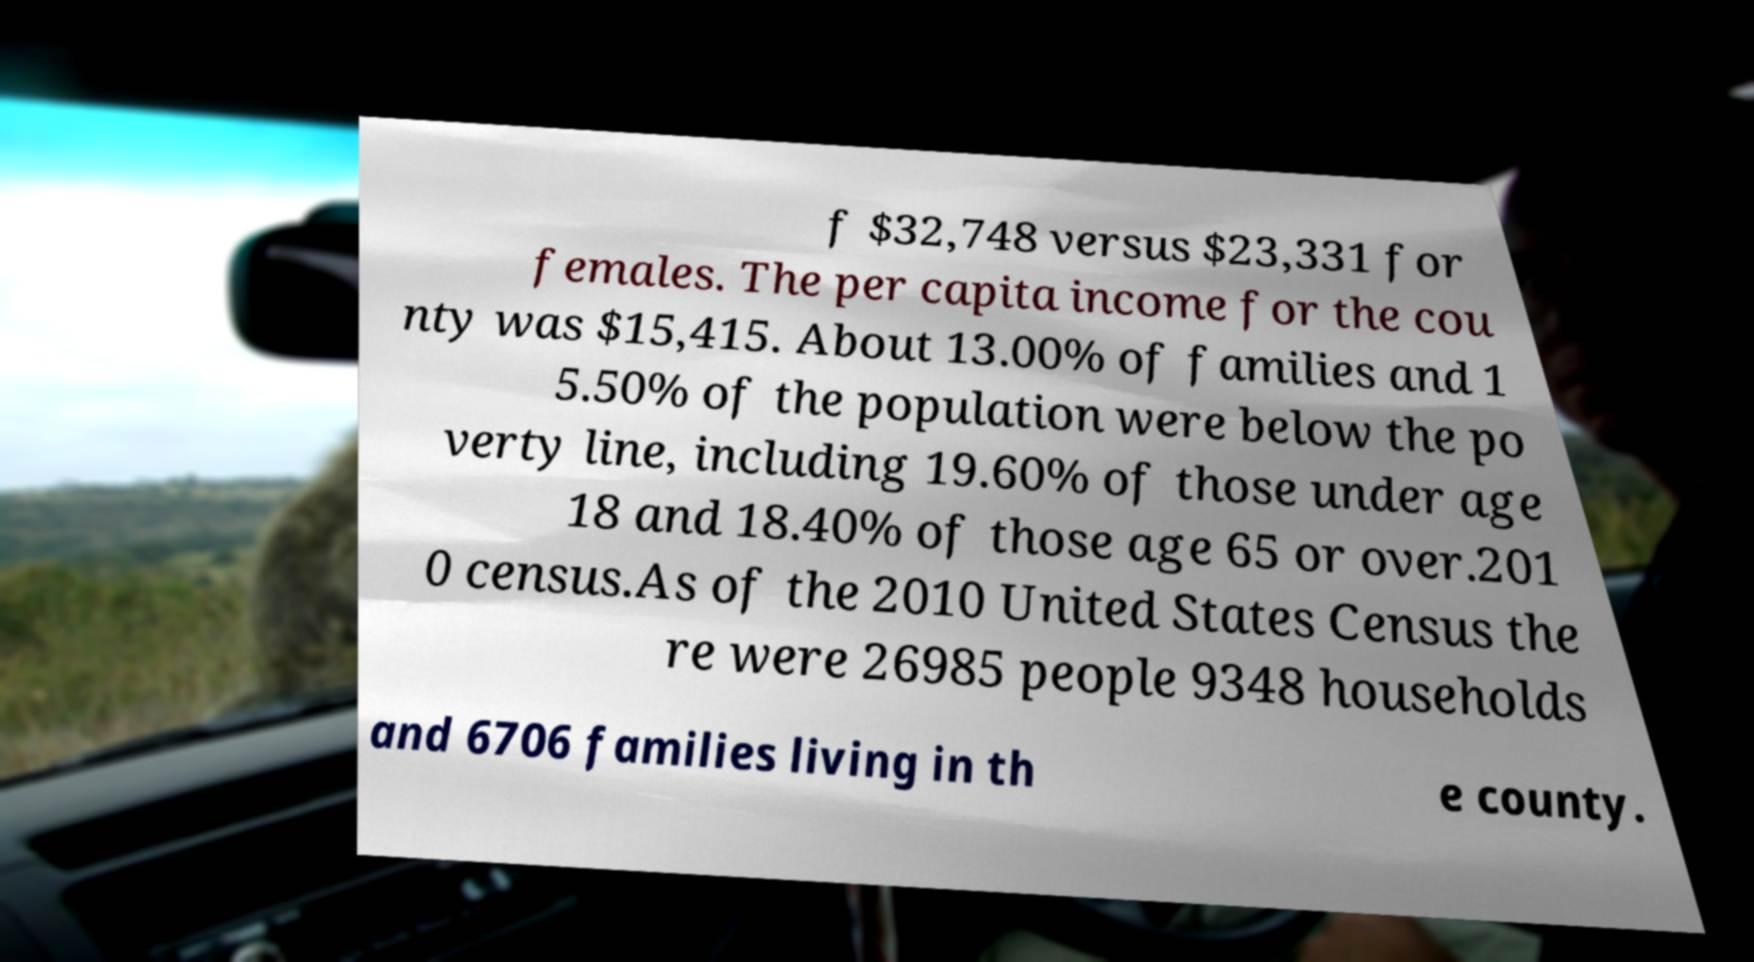For documentation purposes, I need the text within this image transcribed. Could you provide that? f $32,748 versus $23,331 for females. The per capita income for the cou nty was $15,415. About 13.00% of families and 1 5.50% of the population were below the po verty line, including 19.60% of those under age 18 and 18.40% of those age 65 or over.201 0 census.As of the 2010 United States Census the re were 26985 people 9348 households and 6706 families living in th e county. 